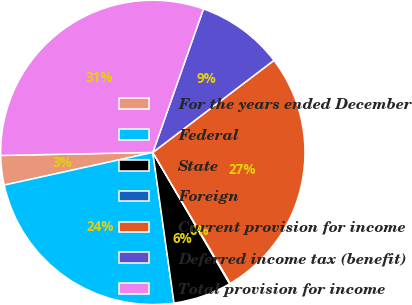Convert chart to OTSL. <chart><loc_0><loc_0><loc_500><loc_500><pie_chart><fcel>For the years ended December<fcel>Federal<fcel>State<fcel>Foreign<fcel>Current provision for income<fcel>Deferred income tax (benefit)<fcel>Total provision for income<nl><fcel>3.13%<fcel>23.78%<fcel>6.2%<fcel>0.07%<fcel>26.85%<fcel>9.26%<fcel>30.72%<nl></chart> 